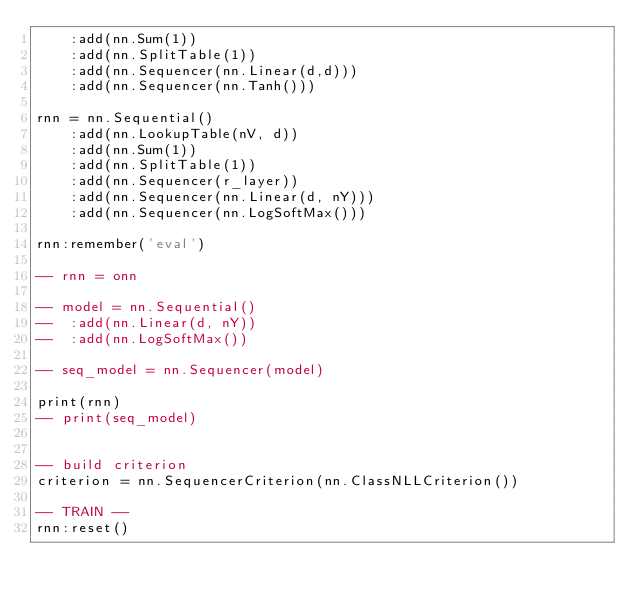Convert code to text. <code><loc_0><loc_0><loc_500><loc_500><_Lua_>	:add(nn.Sum(1))
	:add(nn.SplitTable(1))
	:add(nn.Sequencer(nn.Linear(d,d)))
	:add(nn.Sequencer(nn.Tanh()))

rnn = nn.Sequential()
	:add(nn.LookupTable(nV, d))
	:add(nn.Sum(1))
	:add(nn.SplitTable(1))
	:add(nn.Sequencer(r_layer))
	:add(nn.Sequencer(nn.Linear(d, nY)))
	:add(nn.Sequencer(nn.LogSoftMax()))

rnn:remember('eval')

-- rnn = onn

-- model = nn.Sequential()
-- 	:add(nn.Linear(d, nY))
-- 	:add(nn.LogSoftMax())

-- seq_model = nn.Sequencer(model)

print(rnn)
-- print(seq_model)


-- build criterion
criterion = nn.SequencerCriterion(nn.ClassNLLCriterion())

-- TRAIN --
rnn:reset()</code> 